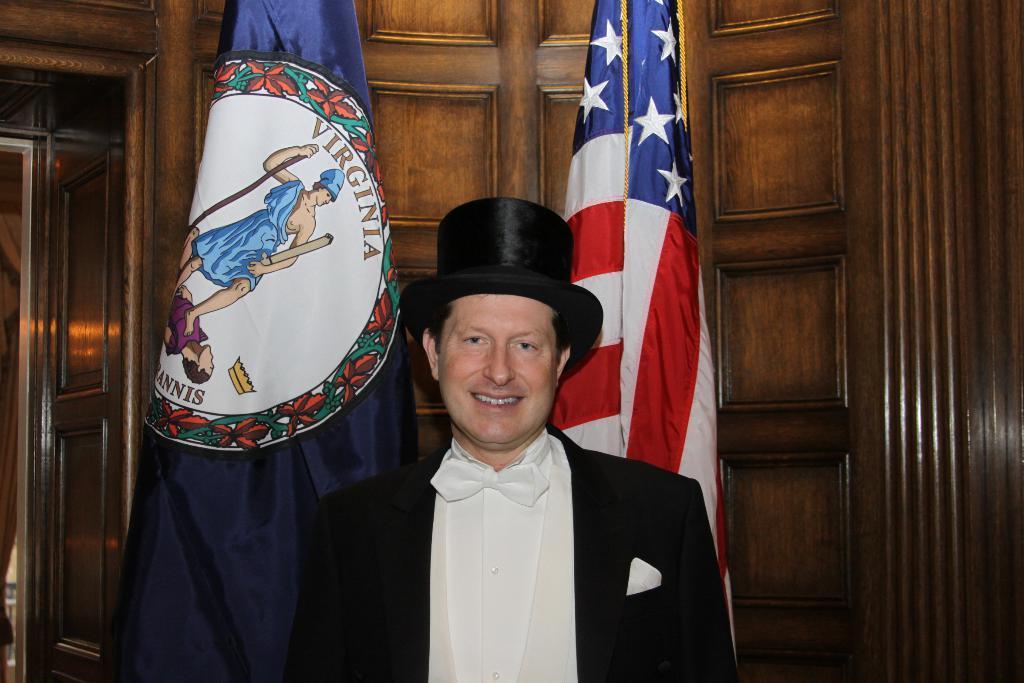Can you describe this image briefly? In the background we can see the wooden wall and the flags. In this picture we can see a man wearing a black cap and a black blazer and he is smiling. 